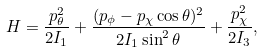<formula> <loc_0><loc_0><loc_500><loc_500>H = { \frac { p _ { \theta } ^ { 2 } } { 2 I _ { 1 } } } + { \frac { ( p _ { \phi } - p _ { \chi } \cos \theta ) ^ { 2 } } { 2 I _ { 1 } \sin ^ { 2 } \theta } } + { \frac { p _ { \chi } ^ { 2 } } { 2 I _ { 3 } } } ,</formula> 